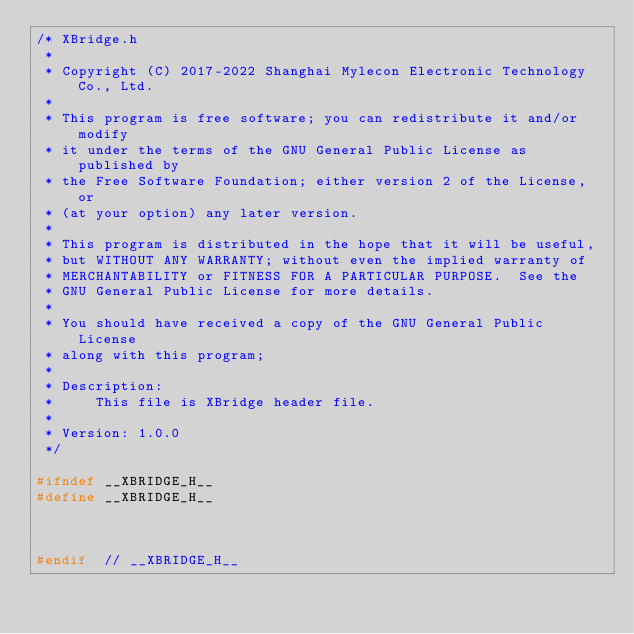<code> <loc_0><loc_0><loc_500><loc_500><_C_>/* XBridge.h
 *
 * Copyright (C) 2017-2022 Shanghai Mylecon Electronic Technology Co., Ltd.
 *
 * This program is free software; you can redistribute it and/or modify
 * it under the terms of the GNU General Public License as published by
 * the Free Software Foundation; either version 2 of the License, or
 * (at your option) any later version.
 *
 * This program is distributed in the hope that it will be useful,
 * but WITHOUT ANY WARRANTY; without even the implied warranty of
 * MERCHANTABILITY or FITNESS FOR A PARTICULAR PURPOSE.  See the
 * GNU General Public License for more details.
 *
 * You should have received a copy of the GNU General Public License
 * along with this program;
 *
 * Description: 
 *     This file is XBridge header file.
 *
 * Version: 1.0.0
 */

#ifndef __XBRIDGE_H__
#define __XBRIDGE_H__



#endif	// __XBRIDGE_H__</code> 